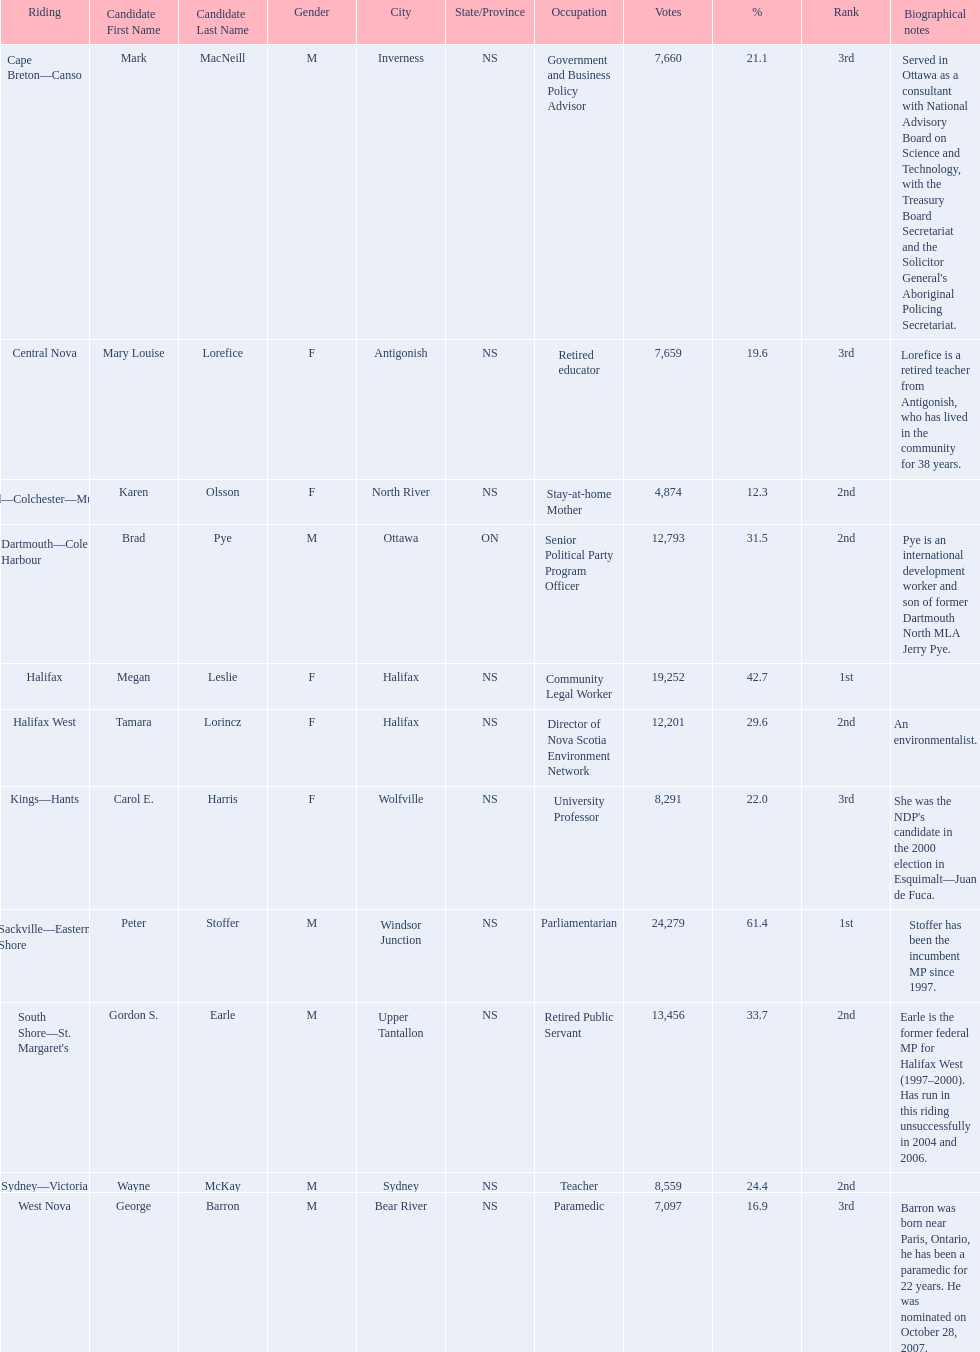Who are all the candidates? Mark MacNeill, Mary Louise Lorefice, Karen Olsson, Brad Pye, Megan Leslie, Tamara Lorincz, Carol E. Harris, Peter Stoffer, Gordon S. Earle, Wayne McKay, George Barron. How many votes did they receive? 7,660, 7,659, 4,874, 12,793, 19,252, 12,201, 8,291, 24,279, 13,456, 8,559, 7,097. And of those, how many were for megan leslie? 19,252. 